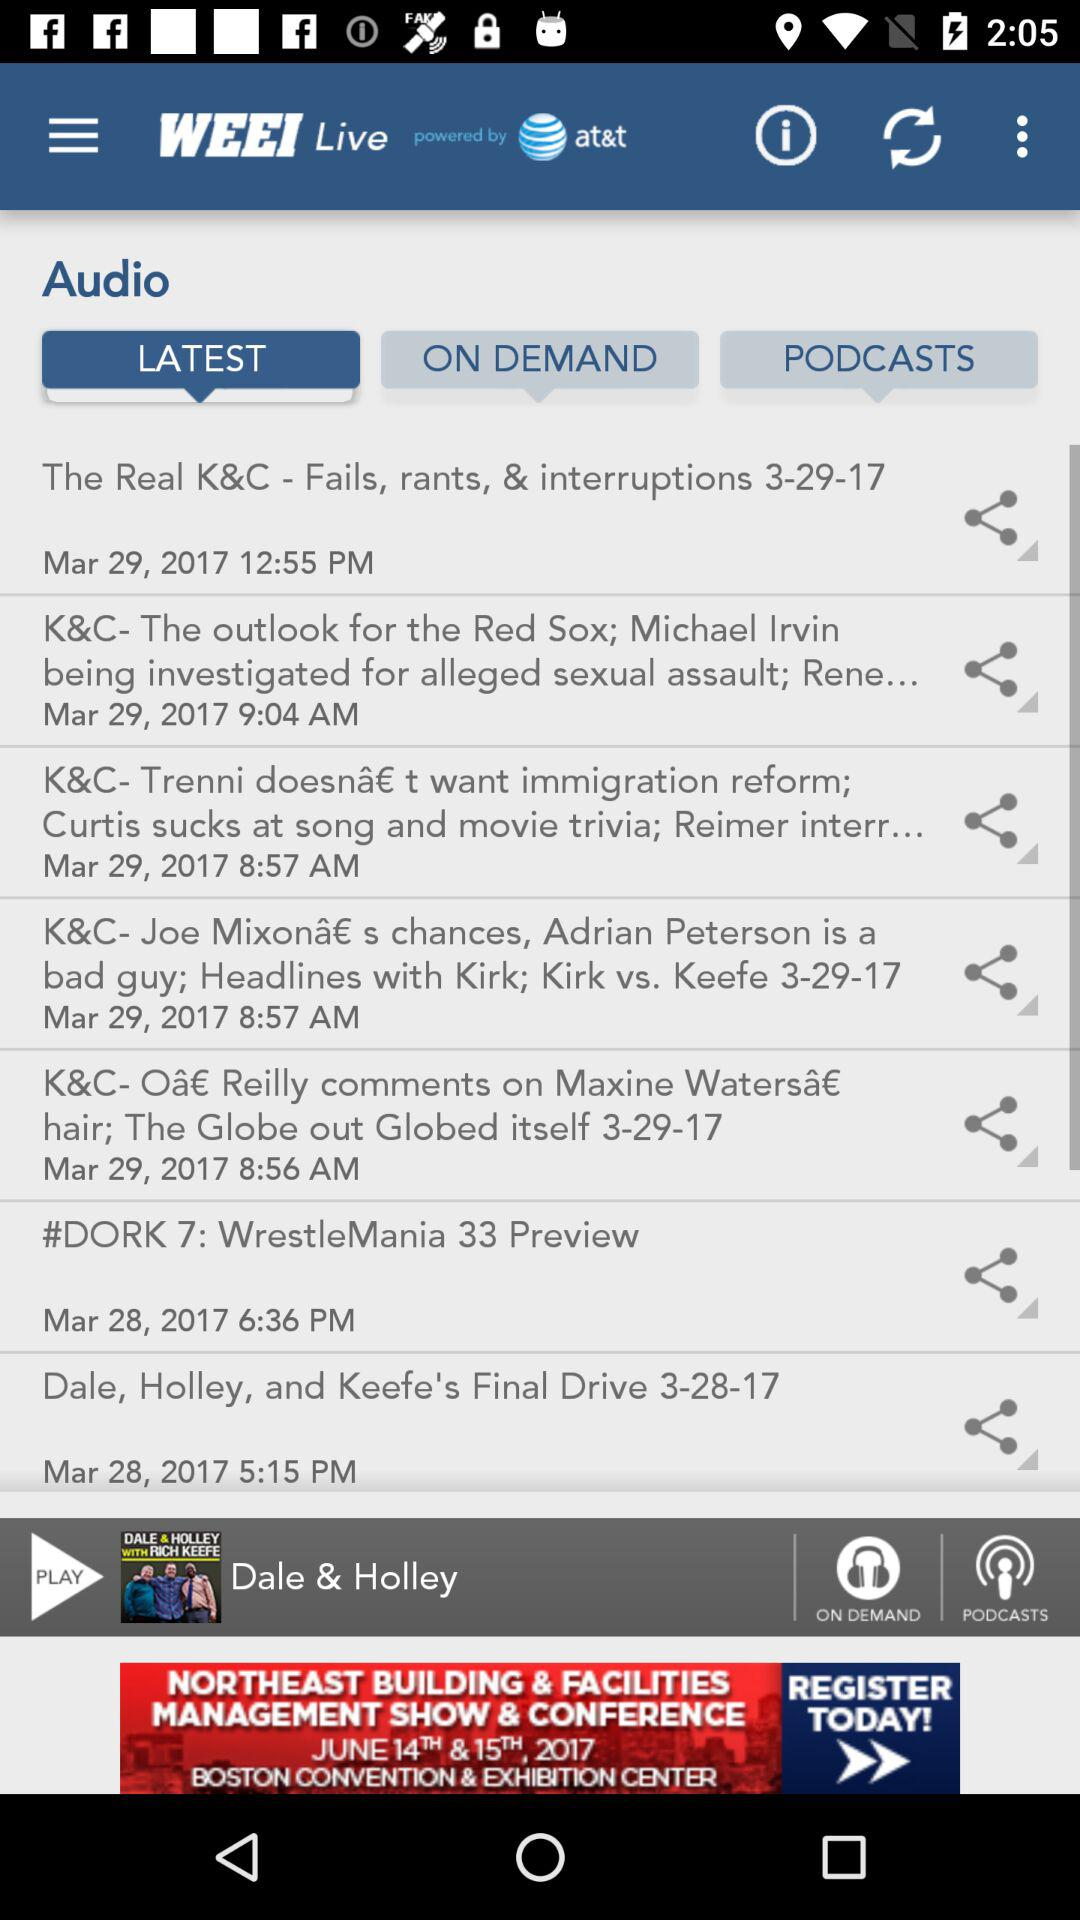Which audio was last played? The last played audio was "Dale & Holley". 